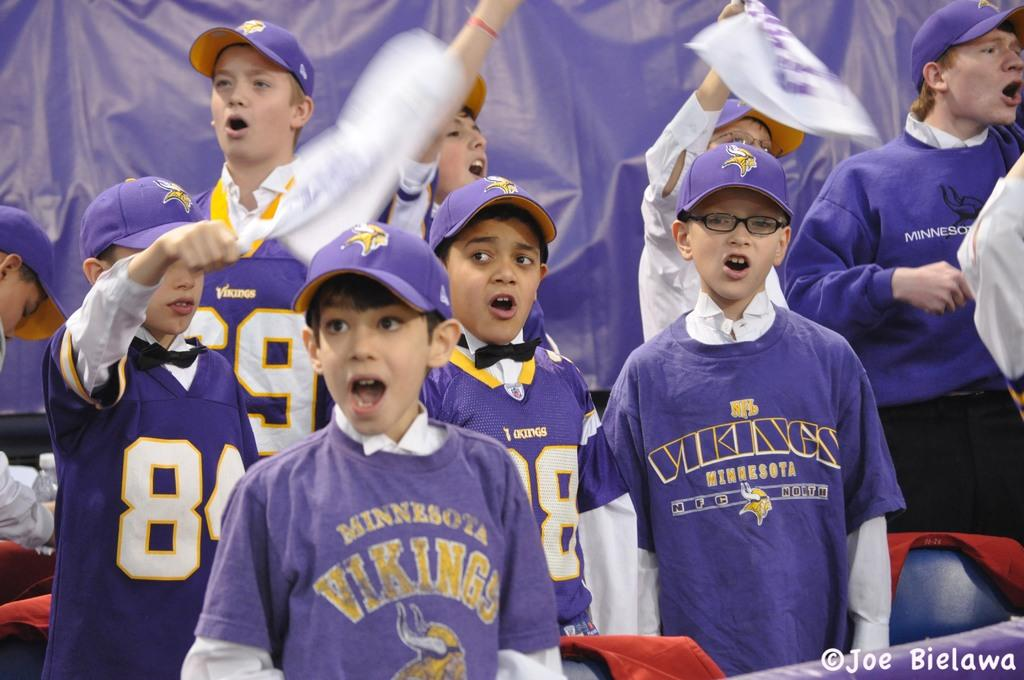<image>
Describe the image concisely. Several young boys wearing purple Minnesota Vikings tops support their team. 